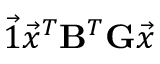<formula> <loc_0><loc_0><loc_500><loc_500>\vec { 1 } \vec { x } ^ { T } B ^ { T } G \vec { x }</formula> 